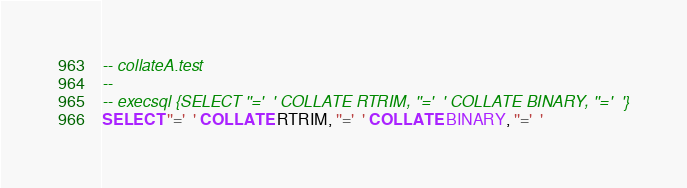Convert code to text. <code><loc_0><loc_0><loc_500><loc_500><_SQL_>-- collateA.test
-- 
-- execsql {SELECT ''='  ' COLLATE RTRIM, ''='  ' COLLATE BINARY, ''='  '}
SELECT ''='  ' COLLATE RTRIM, ''='  ' COLLATE BINARY, ''='  '</code> 